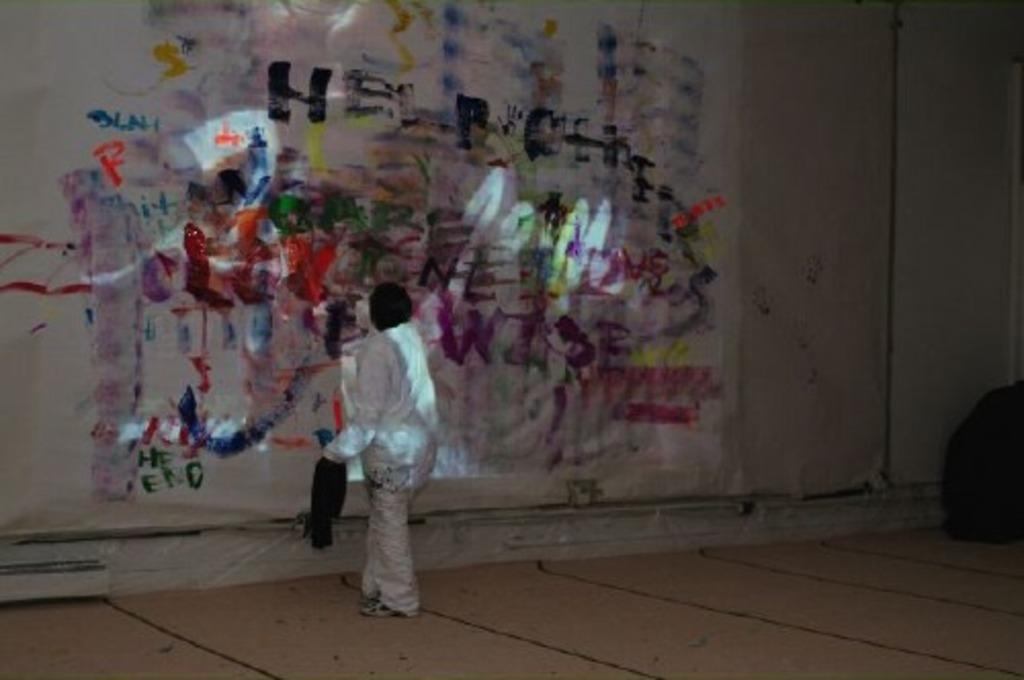Where might the image have been taken? The image might be taken inside a room. Can you describe the person in the image? There is a person in the image, and they are wearing a white dress. What can be seen in the background of the image? There is a wall with paintings in the background of the image. What type of muscle is visible in the image? There is no muscle visible in the image; it features a person wearing a white dress in a room with paintings on the wall. What kind of engine can be seen powering the device in the image? There is no device or engine present in the image. 